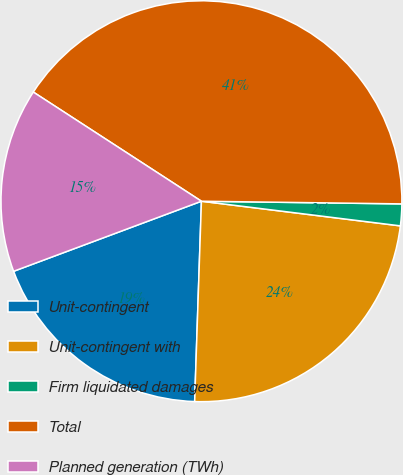Convert chart to OTSL. <chart><loc_0><loc_0><loc_500><loc_500><pie_chart><fcel>Unit-contingent<fcel>Unit-contingent with<fcel>Firm liquidated damages<fcel>Total<fcel>Planned generation (TWh)<nl><fcel>18.78%<fcel>23.58%<fcel>1.75%<fcel>41.05%<fcel>14.85%<nl></chart> 